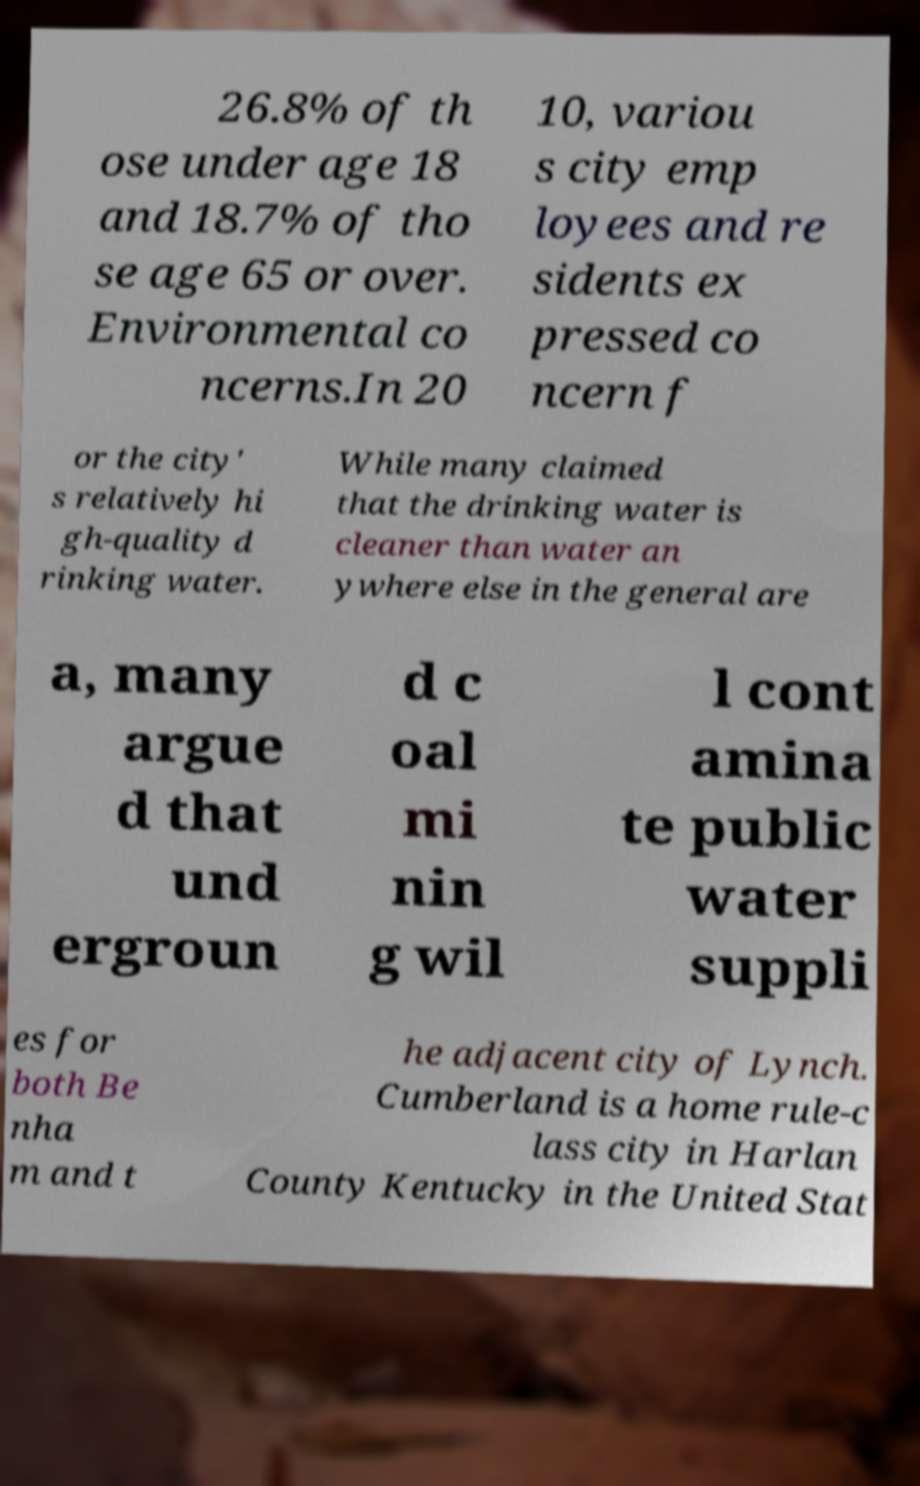Could you extract and type out the text from this image? 26.8% of th ose under age 18 and 18.7% of tho se age 65 or over. Environmental co ncerns.In 20 10, variou s city emp loyees and re sidents ex pressed co ncern f or the city' s relatively hi gh-quality d rinking water. While many claimed that the drinking water is cleaner than water an ywhere else in the general are a, many argue d that und ergroun d c oal mi nin g wil l cont amina te public water suppli es for both Be nha m and t he adjacent city of Lynch. Cumberland is a home rule-c lass city in Harlan County Kentucky in the United Stat 